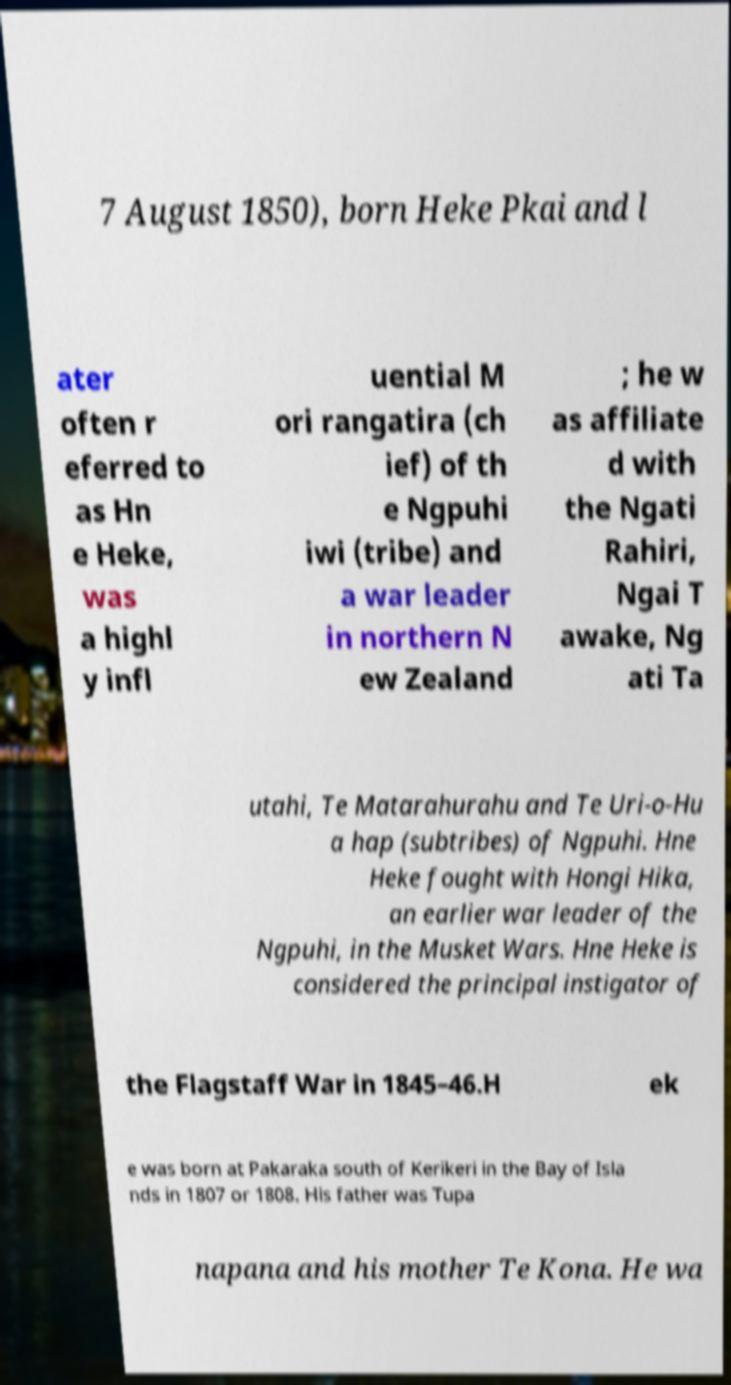Can you accurately transcribe the text from the provided image for me? 7 August 1850), born Heke Pkai and l ater often r eferred to as Hn e Heke, was a highl y infl uential M ori rangatira (ch ief) of th e Ngpuhi iwi (tribe) and a war leader in northern N ew Zealand ; he w as affiliate d with the Ngati Rahiri, Ngai T awake, Ng ati Ta utahi, Te Matarahurahu and Te Uri-o-Hu a hap (subtribes) of Ngpuhi. Hne Heke fought with Hongi Hika, an earlier war leader of the Ngpuhi, in the Musket Wars. Hne Heke is considered the principal instigator of the Flagstaff War in 1845–46.H ek e was born at Pakaraka south of Kerikeri in the Bay of Isla nds in 1807 or 1808. His father was Tupa napana and his mother Te Kona. He wa 